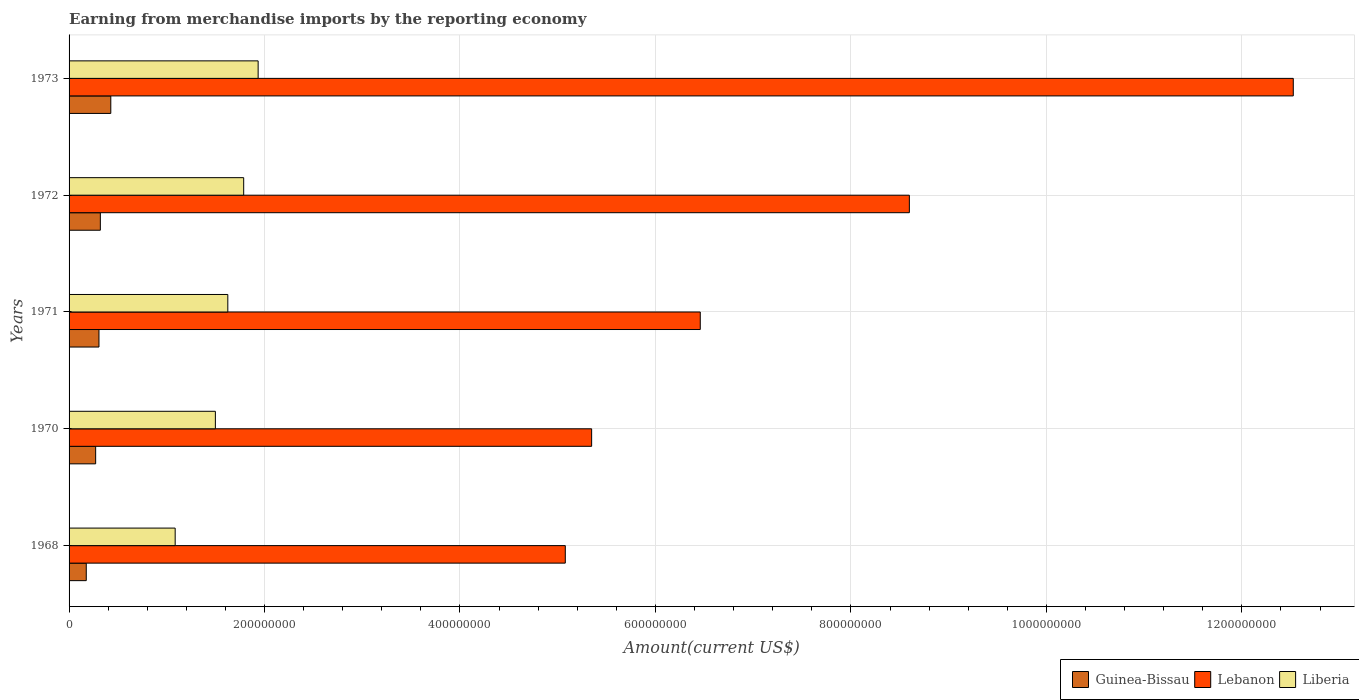How many different coloured bars are there?
Keep it short and to the point. 3. How many groups of bars are there?
Make the answer very short. 5. Are the number of bars per tick equal to the number of legend labels?
Provide a short and direct response. Yes. How many bars are there on the 5th tick from the bottom?
Keep it short and to the point. 3. What is the label of the 2nd group of bars from the top?
Your answer should be very brief. 1972. In how many cases, is the number of bars for a given year not equal to the number of legend labels?
Keep it short and to the point. 0. What is the amount earned from merchandise imports in Lebanon in 1971?
Give a very brief answer. 6.46e+08. Across all years, what is the maximum amount earned from merchandise imports in Guinea-Bissau?
Offer a terse response. 4.27e+07. Across all years, what is the minimum amount earned from merchandise imports in Guinea-Bissau?
Provide a succinct answer. 1.76e+07. In which year was the amount earned from merchandise imports in Guinea-Bissau maximum?
Make the answer very short. 1973. In which year was the amount earned from merchandise imports in Liberia minimum?
Give a very brief answer. 1968. What is the total amount earned from merchandise imports in Lebanon in the graph?
Your answer should be very brief. 3.80e+09. What is the difference between the amount earned from merchandise imports in Liberia in 1968 and that in 1973?
Your answer should be compact. -8.49e+07. What is the difference between the amount earned from merchandise imports in Guinea-Bissau in 1970 and the amount earned from merchandise imports in Liberia in 1971?
Make the answer very short. -1.35e+08. What is the average amount earned from merchandise imports in Liberia per year?
Offer a very short reply. 1.59e+08. In the year 1972, what is the difference between the amount earned from merchandise imports in Guinea-Bissau and amount earned from merchandise imports in Liberia?
Keep it short and to the point. -1.47e+08. What is the ratio of the amount earned from merchandise imports in Liberia in 1971 to that in 1972?
Provide a short and direct response. 0.91. What is the difference between the highest and the second highest amount earned from merchandise imports in Guinea-Bissau?
Give a very brief answer. 1.07e+07. What is the difference between the highest and the lowest amount earned from merchandise imports in Lebanon?
Your answer should be very brief. 7.45e+08. Is the sum of the amount earned from merchandise imports in Lebanon in 1968 and 1970 greater than the maximum amount earned from merchandise imports in Liberia across all years?
Provide a short and direct response. Yes. What does the 3rd bar from the top in 1968 represents?
Your response must be concise. Guinea-Bissau. What does the 1st bar from the bottom in 1970 represents?
Your answer should be compact. Guinea-Bissau. Is it the case that in every year, the sum of the amount earned from merchandise imports in Guinea-Bissau and amount earned from merchandise imports in Lebanon is greater than the amount earned from merchandise imports in Liberia?
Keep it short and to the point. Yes. Are all the bars in the graph horizontal?
Ensure brevity in your answer.  Yes. How many years are there in the graph?
Offer a terse response. 5. What is the difference between two consecutive major ticks on the X-axis?
Your answer should be very brief. 2.00e+08. Does the graph contain grids?
Give a very brief answer. Yes. How are the legend labels stacked?
Your response must be concise. Horizontal. What is the title of the graph?
Give a very brief answer. Earning from merchandise imports by the reporting economy. What is the label or title of the X-axis?
Provide a short and direct response. Amount(current US$). What is the Amount(current US$) of Guinea-Bissau in 1968?
Provide a short and direct response. 1.76e+07. What is the Amount(current US$) in Lebanon in 1968?
Make the answer very short. 5.08e+08. What is the Amount(current US$) in Liberia in 1968?
Offer a very short reply. 1.09e+08. What is the Amount(current US$) in Guinea-Bissau in 1970?
Provide a short and direct response. 2.72e+07. What is the Amount(current US$) in Lebanon in 1970?
Your response must be concise. 5.35e+08. What is the Amount(current US$) in Liberia in 1970?
Provide a short and direct response. 1.50e+08. What is the Amount(current US$) in Guinea-Bissau in 1971?
Provide a short and direct response. 3.06e+07. What is the Amount(current US$) in Lebanon in 1971?
Your answer should be compact. 6.46e+08. What is the Amount(current US$) of Liberia in 1971?
Your response must be concise. 1.62e+08. What is the Amount(current US$) in Guinea-Bissau in 1972?
Give a very brief answer. 3.20e+07. What is the Amount(current US$) of Lebanon in 1972?
Your answer should be compact. 8.60e+08. What is the Amount(current US$) of Liberia in 1972?
Your answer should be very brief. 1.79e+08. What is the Amount(current US$) in Guinea-Bissau in 1973?
Make the answer very short. 4.27e+07. What is the Amount(current US$) of Lebanon in 1973?
Keep it short and to the point. 1.25e+09. What is the Amount(current US$) of Liberia in 1973?
Offer a very short reply. 1.93e+08. Across all years, what is the maximum Amount(current US$) in Guinea-Bissau?
Your response must be concise. 4.27e+07. Across all years, what is the maximum Amount(current US$) in Lebanon?
Provide a succinct answer. 1.25e+09. Across all years, what is the maximum Amount(current US$) in Liberia?
Offer a very short reply. 1.93e+08. Across all years, what is the minimum Amount(current US$) in Guinea-Bissau?
Ensure brevity in your answer.  1.76e+07. Across all years, what is the minimum Amount(current US$) in Lebanon?
Your answer should be compact. 5.08e+08. Across all years, what is the minimum Amount(current US$) of Liberia?
Your answer should be very brief. 1.09e+08. What is the total Amount(current US$) of Guinea-Bissau in the graph?
Your answer should be very brief. 1.50e+08. What is the total Amount(current US$) of Lebanon in the graph?
Your answer should be very brief. 3.80e+09. What is the total Amount(current US$) in Liberia in the graph?
Your answer should be very brief. 7.93e+08. What is the difference between the Amount(current US$) in Guinea-Bissau in 1968 and that in 1970?
Provide a short and direct response. -9.60e+06. What is the difference between the Amount(current US$) in Lebanon in 1968 and that in 1970?
Ensure brevity in your answer.  -2.70e+07. What is the difference between the Amount(current US$) in Liberia in 1968 and that in 1970?
Your answer should be compact. -4.11e+07. What is the difference between the Amount(current US$) of Guinea-Bissau in 1968 and that in 1971?
Provide a short and direct response. -1.30e+07. What is the difference between the Amount(current US$) of Lebanon in 1968 and that in 1971?
Give a very brief answer. -1.38e+08. What is the difference between the Amount(current US$) in Liberia in 1968 and that in 1971?
Offer a very short reply. -5.39e+07. What is the difference between the Amount(current US$) of Guinea-Bissau in 1968 and that in 1972?
Offer a very short reply. -1.44e+07. What is the difference between the Amount(current US$) of Lebanon in 1968 and that in 1972?
Offer a very short reply. -3.52e+08. What is the difference between the Amount(current US$) in Liberia in 1968 and that in 1972?
Your answer should be very brief. -7.01e+07. What is the difference between the Amount(current US$) in Guinea-Bissau in 1968 and that in 1973?
Provide a succinct answer. -2.51e+07. What is the difference between the Amount(current US$) in Lebanon in 1968 and that in 1973?
Your answer should be very brief. -7.45e+08. What is the difference between the Amount(current US$) in Liberia in 1968 and that in 1973?
Provide a short and direct response. -8.49e+07. What is the difference between the Amount(current US$) of Guinea-Bissau in 1970 and that in 1971?
Make the answer very short. -3.40e+06. What is the difference between the Amount(current US$) of Lebanon in 1970 and that in 1971?
Give a very brief answer. -1.11e+08. What is the difference between the Amount(current US$) in Liberia in 1970 and that in 1971?
Keep it short and to the point. -1.27e+07. What is the difference between the Amount(current US$) of Guinea-Bissau in 1970 and that in 1972?
Make the answer very short. -4.80e+06. What is the difference between the Amount(current US$) of Lebanon in 1970 and that in 1972?
Your answer should be very brief. -3.25e+08. What is the difference between the Amount(current US$) in Liberia in 1970 and that in 1972?
Provide a succinct answer. -2.90e+07. What is the difference between the Amount(current US$) of Guinea-Bissau in 1970 and that in 1973?
Give a very brief answer. -1.55e+07. What is the difference between the Amount(current US$) of Lebanon in 1970 and that in 1973?
Provide a short and direct response. -7.18e+08. What is the difference between the Amount(current US$) of Liberia in 1970 and that in 1973?
Your answer should be very brief. -4.38e+07. What is the difference between the Amount(current US$) of Guinea-Bissau in 1971 and that in 1972?
Keep it short and to the point. -1.40e+06. What is the difference between the Amount(current US$) in Lebanon in 1971 and that in 1972?
Provide a short and direct response. -2.14e+08. What is the difference between the Amount(current US$) of Liberia in 1971 and that in 1972?
Provide a succinct answer. -1.63e+07. What is the difference between the Amount(current US$) in Guinea-Bissau in 1971 and that in 1973?
Offer a very short reply. -1.21e+07. What is the difference between the Amount(current US$) in Lebanon in 1971 and that in 1973?
Provide a succinct answer. -6.07e+08. What is the difference between the Amount(current US$) in Liberia in 1971 and that in 1973?
Give a very brief answer. -3.10e+07. What is the difference between the Amount(current US$) in Guinea-Bissau in 1972 and that in 1973?
Provide a succinct answer. -1.07e+07. What is the difference between the Amount(current US$) of Lebanon in 1972 and that in 1973?
Ensure brevity in your answer.  -3.93e+08. What is the difference between the Amount(current US$) of Liberia in 1972 and that in 1973?
Your answer should be very brief. -1.48e+07. What is the difference between the Amount(current US$) in Guinea-Bissau in 1968 and the Amount(current US$) in Lebanon in 1970?
Your answer should be compact. -5.17e+08. What is the difference between the Amount(current US$) in Guinea-Bissau in 1968 and the Amount(current US$) in Liberia in 1970?
Give a very brief answer. -1.32e+08. What is the difference between the Amount(current US$) in Lebanon in 1968 and the Amount(current US$) in Liberia in 1970?
Make the answer very short. 3.58e+08. What is the difference between the Amount(current US$) in Guinea-Bissau in 1968 and the Amount(current US$) in Lebanon in 1971?
Offer a very short reply. -6.28e+08. What is the difference between the Amount(current US$) of Guinea-Bissau in 1968 and the Amount(current US$) of Liberia in 1971?
Give a very brief answer. -1.45e+08. What is the difference between the Amount(current US$) of Lebanon in 1968 and the Amount(current US$) of Liberia in 1971?
Give a very brief answer. 3.45e+08. What is the difference between the Amount(current US$) of Guinea-Bissau in 1968 and the Amount(current US$) of Lebanon in 1972?
Your answer should be very brief. -8.42e+08. What is the difference between the Amount(current US$) of Guinea-Bissau in 1968 and the Amount(current US$) of Liberia in 1972?
Ensure brevity in your answer.  -1.61e+08. What is the difference between the Amount(current US$) of Lebanon in 1968 and the Amount(current US$) of Liberia in 1972?
Your answer should be compact. 3.29e+08. What is the difference between the Amount(current US$) of Guinea-Bissau in 1968 and the Amount(current US$) of Lebanon in 1973?
Provide a short and direct response. -1.24e+09. What is the difference between the Amount(current US$) in Guinea-Bissau in 1968 and the Amount(current US$) in Liberia in 1973?
Provide a succinct answer. -1.76e+08. What is the difference between the Amount(current US$) in Lebanon in 1968 and the Amount(current US$) in Liberia in 1973?
Keep it short and to the point. 3.14e+08. What is the difference between the Amount(current US$) in Guinea-Bissau in 1970 and the Amount(current US$) in Lebanon in 1971?
Give a very brief answer. -6.19e+08. What is the difference between the Amount(current US$) of Guinea-Bissau in 1970 and the Amount(current US$) of Liberia in 1971?
Provide a short and direct response. -1.35e+08. What is the difference between the Amount(current US$) of Lebanon in 1970 and the Amount(current US$) of Liberia in 1971?
Give a very brief answer. 3.72e+08. What is the difference between the Amount(current US$) in Guinea-Bissau in 1970 and the Amount(current US$) in Lebanon in 1972?
Provide a succinct answer. -8.33e+08. What is the difference between the Amount(current US$) of Guinea-Bissau in 1970 and the Amount(current US$) of Liberia in 1972?
Make the answer very short. -1.51e+08. What is the difference between the Amount(current US$) of Lebanon in 1970 and the Amount(current US$) of Liberia in 1972?
Provide a succinct answer. 3.56e+08. What is the difference between the Amount(current US$) in Guinea-Bissau in 1970 and the Amount(current US$) in Lebanon in 1973?
Ensure brevity in your answer.  -1.23e+09. What is the difference between the Amount(current US$) in Guinea-Bissau in 1970 and the Amount(current US$) in Liberia in 1973?
Your answer should be compact. -1.66e+08. What is the difference between the Amount(current US$) of Lebanon in 1970 and the Amount(current US$) of Liberia in 1973?
Your response must be concise. 3.41e+08. What is the difference between the Amount(current US$) in Guinea-Bissau in 1971 and the Amount(current US$) in Lebanon in 1972?
Make the answer very short. -8.29e+08. What is the difference between the Amount(current US$) in Guinea-Bissau in 1971 and the Amount(current US$) in Liberia in 1972?
Offer a very short reply. -1.48e+08. What is the difference between the Amount(current US$) of Lebanon in 1971 and the Amount(current US$) of Liberia in 1972?
Your response must be concise. 4.67e+08. What is the difference between the Amount(current US$) of Guinea-Bissau in 1971 and the Amount(current US$) of Lebanon in 1973?
Make the answer very short. -1.22e+09. What is the difference between the Amount(current US$) in Guinea-Bissau in 1971 and the Amount(current US$) in Liberia in 1973?
Your answer should be compact. -1.63e+08. What is the difference between the Amount(current US$) of Lebanon in 1971 and the Amount(current US$) of Liberia in 1973?
Make the answer very short. 4.52e+08. What is the difference between the Amount(current US$) of Guinea-Bissau in 1972 and the Amount(current US$) of Lebanon in 1973?
Provide a succinct answer. -1.22e+09. What is the difference between the Amount(current US$) of Guinea-Bissau in 1972 and the Amount(current US$) of Liberia in 1973?
Ensure brevity in your answer.  -1.61e+08. What is the difference between the Amount(current US$) of Lebanon in 1972 and the Amount(current US$) of Liberia in 1973?
Provide a succinct answer. 6.66e+08. What is the average Amount(current US$) in Guinea-Bissau per year?
Provide a succinct answer. 3.00e+07. What is the average Amount(current US$) in Lebanon per year?
Ensure brevity in your answer.  7.60e+08. What is the average Amount(current US$) of Liberia per year?
Provide a succinct answer. 1.59e+08. In the year 1968, what is the difference between the Amount(current US$) of Guinea-Bissau and Amount(current US$) of Lebanon?
Your response must be concise. -4.90e+08. In the year 1968, what is the difference between the Amount(current US$) in Guinea-Bissau and Amount(current US$) in Liberia?
Give a very brief answer. -9.10e+07. In the year 1968, what is the difference between the Amount(current US$) of Lebanon and Amount(current US$) of Liberia?
Give a very brief answer. 3.99e+08. In the year 1970, what is the difference between the Amount(current US$) in Guinea-Bissau and Amount(current US$) in Lebanon?
Give a very brief answer. -5.08e+08. In the year 1970, what is the difference between the Amount(current US$) of Guinea-Bissau and Amount(current US$) of Liberia?
Your response must be concise. -1.22e+08. In the year 1970, what is the difference between the Amount(current US$) of Lebanon and Amount(current US$) of Liberia?
Offer a terse response. 3.85e+08. In the year 1971, what is the difference between the Amount(current US$) in Guinea-Bissau and Amount(current US$) in Lebanon?
Offer a very short reply. -6.15e+08. In the year 1971, what is the difference between the Amount(current US$) in Guinea-Bissau and Amount(current US$) in Liberia?
Provide a short and direct response. -1.32e+08. In the year 1971, what is the difference between the Amount(current US$) in Lebanon and Amount(current US$) in Liberia?
Offer a terse response. 4.83e+08. In the year 1972, what is the difference between the Amount(current US$) of Guinea-Bissau and Amount(current US$) of Lebanon?
Keep it short and to the point. -8.28e+08. In the year 1972, what is the difference between the Amount(current US$) in Guinea-Bissau and Amount(current US$) in Liberia?
Offer a terse response. -1.47e+08. In the year 1972, what is the difference between the Amount(current US$) in Lebanon and Amount(current US$) in Liberia?
Make the answer very short. 6.81e+08. In the year 1973, what is the difference between the Amount(current US$) in Guinea-Bissau and Amount(current US$) in Lebanon?
Provide a succinct answer. -1.21e+09. In the year 1973, what is the difference between the Amount(current US$) of Guinea-Bissau and Amount(current US$) of Liberia?
Give a very brief answer. -1.51e+08. In the year 1973, what is the difference between the Amount(current US$) in Lebanon and Amount(current US$) in Liberia?
Your answer should be very brief. 1.06e+09. What is the ratio of the Amount(current US$) of Guinea-Bissau in 1968 to that in 1970?
Offer a very short reply. 0.65. What is the ratio of the Amount(current US$) in Lebanon in 1968 to that in 1970?
Your answer should be very brief. 0.95. What is the ratio of the Amount(current US$) in Liberia in 1968 to that in 1970?
Provide a short and direct response. 0.73. What is the ratio of the Amount(current US$) of Guinea-Bissau in 1968 to that in 1971?
Give a very brief answer. 0.58. What is the ratio of the Amount(current US$) in Lebanon in 1968 to that in 1971?
Offer a very short reply. 0.79. What is the ratio of the Amount(current US$) in Liberia in 1968 to that in 1971?
Make the answer very short. 0.67. What is the ratio of the Amount(current US$) of Guinea-Bissau in 1968 to that in 1972?
Ensure brevity in your answer.  0.55. What is the ratio of the Amount(current US$) in Lebanon in 1968 to that in 1972?
Your answer should be very brief. 0.59. What is the ratio of the Amount(current US$) in Liberia in 1968 to that in 1972?
Make the answer very short. 0.61. What is the ratio of the Amount(current US$) in Guinea-Bissau in 1968 to that in 1973?
Offer a very short reply. 0.41. What is the ratio of the Amount(current US$) in Lebanon in 1968 to that in 1973?
Your response must be concise. 0.41. What is the ratio of the Amount(current US$) of Liberia in 1968 to that in 1973?
Offer a terse response. 0.56. What is the ratio of the Amount(current US$) of Guinea-Bissau in 1970 to that in 1971?
Provide a succinct answer. 0.89. What is the ratio of the Amount(current US$) in Lebanon in 1970 to that in 1971?
Make the answer very short. 0.83. What is the ratio of the Amount(current US$) of Liberia in 1970 to that in 1971?
Offer a terse response. 0.92. What is the ratio of the Amount(current US$) in Guinea-Bissau in 1970 to that in 1972?
Your answer should be compact. 0.85. What is the ratio of the Amount(current US$) in Lebanon in 1970 to that in 1972?
Your response must be concise. 0.62. What is the ratio of the Amount(current US$) in Liberia in 1970 to that in 1972?
Provide a succinct answer. 0.84. What is the ratio of the Amount(current US$) in Guinea-Bissau in 1970 to that in 1973?
Keep it short and to the point. 0.64. What is the ratio of the Amount(current US$) in Lebanon in 1970 to that in 1973?
Keep it short and to the point. 0.43. What is the ratio of the Amount(current US$) of Liberia in 1970 to that in 1973?
Offer a very short reply. 0.77. What is the ratio of the Amount(current US$) in Guinea-Bissau in 1971 to that in 1972?
Your response must be concise. 0.96. What is the ratio of the Amount(current US$) of Lebanon in 1971 to that in 1972?
Your answer should be compact. 0.75. What is the ratio of the Amount(current US$) of Liberia in 1971 to that in 1972?
Ensure brevity in your answer.  0.91. What is the ratio of the Amount(current US$) of Guinea-Bissau in 1971 to that in 1973?
Make the answer very short. 0.72. What is the ratio of the Amount(current US$) in Lebanon in 1971 to that in 1973?
Provide a short and direct response. 0.52. What is the ratio of the Amount(current US$) in Liberia in 1971 to that in 1973?
Make the answer very short. 0.84. What is the ratio of the Amount(current US$) of Guinea-Bissau in 1972 to that in 1973?
Offer a very short reply. 0.75. What is the ratio of the Amount(current US$) of Lebanon in 1972 to that in 1973?
Ensure brevity in your answer.  0.69. What is the ratio of the Amount(current US$) of Liberia in 1972 to that in 1973?
Provide a short and direct response. 0.92. What is the difference between the highest and the second highest Amount(current US$) in Guinea-Bissau?
Give a very brief answer. 1.07e+07. What is the difference between the highest and the second highest Amount(current US$) in Lebanon?
Provide a short and direct response. 3.93e+08. What is the difference between the highest and the second highest Amount(current US$) of Liberia?
Your answer should be very brief. 1.48e+07. What is the difference between the highest and the lowest Amount(current US$) in Guinea-Bissau?
Provide a short and direct response. 2.51e+07. What is the difference between the highest and the lowest Amount(current US$) in Lebanon?
Keep it short and to the point. 7.45e+08. What is the difference between the highest and the lowest Amount(current US$) in Liberia?
Your answer should be very brief. 8.49e+07. 